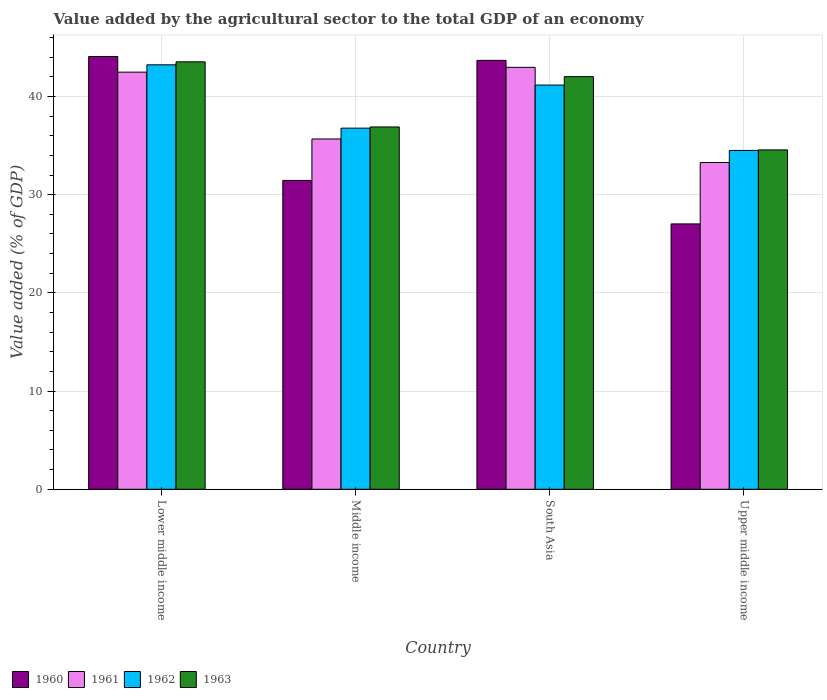How many bars are there on the 4th tick from the right?
Your response must be concise. 4. What is the label of the 2nd group of bars from the left?
Your answer should be very brief. Middle income. What is the value added by the agricultural sector to the total GDP in 1960 in Upper middle income?
Your response must be concise. 27.02. Across all countries, what is the maximum value added by the agricultural sector to the total GDP in 1963?
Offer a very short reply. 43.53. Across all countries, what is the minimum value added by the agricultural sector to the total GDP in 1963?
Offer a very short reply. 34.56. In which country was the value added by the agricultural sector to the total GDP in 1963 maximum?
Your answer should be very brief. Lower middle income. In which country was the value added by the agricultural sector to the total GDP in 1963 minimum?
Offer a very short reply. Upper middle income. What is the total value added by the agricultural sector to the total GDP in 1960 in the graph?
Ensure brevity in your answer.  146.22. What is the difference between the value added by the agricultural sector to the total GDP in 1963 in Middle income and that in South Asia?
Offer a very short reply. -5.13. What is the difference between the value added by the agricultural sector to the total GDP in 1962 in South Asia and the value added by the agricultural sector to the total GDP in 1963 in Middle income?
Your answer should be very brief. 4.27. What is the average value added by the agricultural sector to the total GDP in 1960 per country?
Provide a succinct answer. 36.55. What is the difference between the value added by the agricultural sector to the total GDP of/in 1961 and value added by the agricultural sector to the total GDP of/in 1963 in South Asia?
Your answer should be compact. 0.95. What is the ratio of the value added by the agricultural sector to the total GDP in 1961 in Lower middle income to that in South Asia?
Provide a succinct answer. 0.99. What is the difference between the highest and the second highest value added by the agricultural sector to the total GDP in 1961?
Offer a very short reply. 7.29. What is the difference between the highest and the lowest value added by the agricultural sector to the total GDP in 1960?
Offer a very short reply. 17.05. How many countries are there in the graph?
Your answer should be very brief. 4. Are the values on the major ticks of Y-axis written in scientific E-notation?
Give a very brief answer. No. Does the graph contain any zero values?
Ensure brevity in your answer.  No. What is the title of the graph?
Make the answer very short. Value added by the agricultural sector to the total GDP of an economy. Does "1997" appear as one of the legend labels in the graph?
Keep it short and to the point. No. What is the label or title of the X-axis?
Provide a succinct answer. Country. What is the label or title of the Y-axis?
Offer a terse response. Value added (% of GDP). What is the Value added (% of GDP) in 1960 in Lower middle income?
Provide a succinct answer. 44.07. What is the Value added (% of GDP) in 1961 in Lower middle income?
Make the answer very short. 42.48. What is the Value added (% of GDP) of 1962 in Lower middle income?
Provide a succinct answer. 43.22. What is the Value added (% of GDP) of 1963 in Lower middle income?
Offer a terse response. 43.53. What is the Value added (% of GDP) in 1960 in Middle income?
Ensure brevity in your answer.  31.45. What is the Value added (% of GDP) in 1961 in Middle income?
Offer a very short reply. 35.67. What is the Value added (% of GDP) in 1962 in Middle income?
Offer a very short reply. 36.77. What is the Value added (% of GDP) in 1963 in Middle income?
Offer a terse response. 36.89. What is the Value added (% of GDP) of 1960 in South Asia?
Offer a very short reply. 43.68. What is the Value added (% of GDP) in 1961 in South Asia?
Your answer should be compact. 42.96. What is the Value added (% of GDP) of 1962 in South Asia?
Provide a short and direct response. 41.16. What is the Value added (% of GDP) of 1963 in South Asia?
Your response must be concise. 42.02. What is the Value added (% of GDP) of 1960 in Upper middle income?
Give a very brief answer. 27.02. What is the Value added (% of GDP) of 1961 in Upper middle income?
Ensure brevity in your answer.  33.27. What is the Value added (% of GDP) in 1962 in Upper middle income?
Give a very brief answer. 34.5. What is the Value added (% of GDP) in 1963 in Upper middle income?
Offer a terse response. 34.56. Across all countries, what is the maximum Value added (% of GDP) of 1960?
Keep it short and to the point. 44.07. Across all countries, what is the maximum Value added (% of GDP) in 1961?
Keep it short and to the point. 42.96. Across all countries, what is the maximum Value added (% of GDP) of 1962?
Ensure brevity in your answer.  43.22. Across all countries, what is the maximum Value added (% of GDP) of 1963?
Ensure brevity in your answer.  43.53. Across all countries, what is the minimum Value added (% of GDP) in 1960?
Give a very brief answer. 27.02. Across all countries, what is the minimum Value added (% of GDP) of 1961?
Give a very brief answer. 33.27. Across all countries, what is the minimum Value added (% of GDP) of 1962?
Your response must be concise. 34.5. Across all countries, what is the minimum Value added (% of GDP) of 1963?
Give a very brief answer. 34.56. What is the total Value added (% of GDP) in 1960 in the graph?
Your answer should be compact. 146.22. What is the total Value added (% of GDP) of 1961 in the graph?
Provide a succinct answer. 154.39. What is the total Value added (% of GDP) in 1962 in the graph?
Keep it short and to the point. 155.66. What is the total Value added (% of GDP) in 1963 in the graph?
Your answer should be compact. 157. What is the difference between the Value added (% of GDP) of 1960 in Lower middle income and that in Middle income?
Provide a succinct answer. 12.62. What is the difference between the Value added (% of GDP) in 1961 in Lower middle income and that in Middle income?
Your response must be concise. 6.81. What is the difference between the Value added (% of GDP) of 1962 in Lower middle income and that in Middle income?
Your response must be concise. 6.45. What is the difference between the Value added (% of GDP) in 1963 in Lower middle income and that in Middle income?
Provide a succinct answer. 6.63. What is the difference between the Value added (% of GDP) in 1960 in Lower middle income and that in South Asia?
Make the answer very short. 0.39. What is the difference between the Value added (% of GDP) of 1961 in Lower middle income and that in South Asia?
Ensure brevity in your answer.  -0.49. What is the difference between the Value added (% of GDP) of 1962 in Lower middle income and that in South Asia?
Ensure brevity in your answer.  2.06. What is the difference between the Value added (% of GDP) in 1963 in Lower middle income and that in South Asia?
Your answer should be compact. 1.51. What is the difference between the Value added (% of GDP) of 1960 in Lower middle income and that in Upper middle income?
Keep it short and to the point. 17.05. What is the difference between the Value added (% of GDP) in 1961 in Lower middle income and that in Upper middle income?
Provide a short and direct response. 9.2. What is the difference between the Value added (% of GDP) in 1962 in Lower middle income and that in Upper middle income?
Make the answer very short. 8.72. What is the difference between the Value added (% of GDP) in 1963 in Lower middle income and that in Upper middle income?
Provide a succinct answer. 8.97. What is the difference between the Value added (% of GDP) in 1960 in Middle income and that in South Asia?
Provide a succinct answer. -12.22. What is the difference between the Value added (% of GDP) of 1961 in Middle income and that in South Asia?
Offer a very short reply. -7.29. What is the difference between the Value added (% of GDP) of 1962 in Middle income and that in South Asia?
Your answer should be compact. -4.39. What is the difference between the Value added (% of GDP) of 1963 in Middle income and that in South Asia?
Your answer should be compact. -5.13. What is the difference between the Value added (% of GDP) of 1960 in Middle income and that in Upper middle income?
Keep it short and to the point. 4.43. What is the difference between the Value added (% of GDP) of 1961 in Middle income and that in Upper middle income?
Offer a very short reply. 2.4. What is the difference between the Value added (% of GDP) of 1962 in Middle income and that in Upper middle income?
Your answer should be compact. 2.27. What is the difference between the Value added (% of GDP) of 1963 in Middle income and that in Upper middle income?
Your response must be concise. 2.33. What is the difference between the Value added (% of GDP) of 1960 in South Asia and that in Upper middle income?
Your answer should be compact. 16.65. What is the difference between the Value added (% of GDP) in 1961 in South Asia and that in Upper middle income?
Your response must be concise. 9.69. What is the difference between the Value added (% of GDP) in 1962 in South Asia and that in Upper middle income?
Offer a very short reply. 6.66. What is the difference between the Value added (% of GDP) of 1963 in South Asia and that in Upper middle income?
Offer a terse response. 7.46. What is the difference between the Value added (% of GDP) in 1960 in Lower middle income and the Value added (% of GDP) in 1961 in Middle income?
Make the answer very short. 8.4. What is the difference between the Value added (% of GDP) of 1960 in Lower middle income and the Value added (% of GDP) of 1962 in Middle income?
Keep it short and to the point. 7.29. What is the difference between the Value added (% of GDP) of 1960 in Lower middle income and the Value added (% of GDP) of 1963 in Middle income?
Provide a short and direct response. 7.17. What is the difference between the Value added (% of GDP) of 1961 in Lower middle income and the Value added (% of GDP) of 1962 in Middle income?
Offer a very short reply. 5.7. What is the difference between the Value added (% of GDP) in 1961 in Lower middle income and the Value added (% of GDP) in 1963 in Middle income?
Your response must be concise. 5.58. What is the difference between the Value added (% of GDP) of 1962 in Lower middle income and the Value added (% of GDP) of 1963 in Middle income?
Make the answer very short. 6.33. What is the difference between the Value added (% of GDP) of 1960 in Lower middle income and the Value added (% of GDP) of 1961 in South Asia?
Provide a succinct answer. 1.1. What is the difference between the Value added (% of GDP) of 1960 in Lower middle income and the Value added (% of GDP) of 1962 in South Asia?
Keep it short and to the point. 2.91. What is the difference between the Value added (% of GDP) in 1960 in Lower middle income and the Value added (% of GDP) in 1963 in South Asia?
Ensure brevity in your answer.  2.05. What is the difference between the Value added (% of GDP) in 1961 in Lower middle income and the Value added (% of GDP) in 1962 in South Asia?
Your answer should be very brief. 1.32. What is the difference between the Value added (% of GDP) of 1961 in Lower middle income and the Value added (% of GDP) of 1963 in South Asia?
Provide a succinct answer. 0.46. What is the difference between the Value added (% of GDP) of 1962 in Lower middle income and the Value added (% of GDP) of 1963 in South Asia?
Ensure brevity in your answer.  1.2. What is the difference between the Value added (% of GDP) of 1960 in Lower middle income and the Value added (% of GDP) of 1961 in Upper middle income?
Your answer should be compact. 10.79. What is the difference between the Value added (% of GDP) of 1960 in Lower middle income and the Value added (% of GDP) of 1962 in Upper middle income?
Offer a very short reply. 9.56. What is the difference between the Value added (% of GDP) in 1960 in Lower middle income and the Value added (% of GDP) in 1963 in Upper middle income?
Keep it short and to the point. 9.51. What is the difference between the Value added (% of GDP) in 1961 in Lower middle income and the Value added (% of GDP) in 1962 in Upper middle income?
Provide a short and direct response. 7.97. What is the difference between the Value added (% of GDP) of 1961 in Lower middle income and the Value added (% of GDP) of 1963 in Upper middle income?
Your response must be concise. 7.92. What is the difference between the Value added (% of GDP) in 1962 in Lower middle income and the Value added (% of GDP) in 1963 in Upper middle income?
Keep it short and to the point. 8.66. What is the difference between the Value added (% of GDP) in 1960 in Middle income and the Value added (% of GDP) in 1961 in South Asia?
Provide a short and direct response. -11.51. What is the difference between the Value added (% of GDP) in 1960 in Middle income and the Value added (% of GDP) in 1962 in South Asia?
Ensure brevity in your answer.  -9.71. What is the difference between the Value added (% of GDP) in 1960 in Middle income and the Value added (% of GDP) in 1963 in South Asia?
Your answer should be very brief. -10.57. What is the difference between the Value added (% of GDP) in 1961 in Middle income and the Value added (% of GDP) in 1962 in South Asia?
Your answer should be compact. -5.49. What is the difference between the Value added (% of GDP) of 1961 in Middle income and the Value added (% of GDP) of 1963 in South Asia?
Offer a very short reply. -6.35. What is the difference between the Value added (% of GDP) in 1962 in Middle income and the Value added (% of GDP) in 1963 in South Asia?
Your answer should be compact. -5.25. What is the difference between the Value added (% of GDP) of 1960 in Middle income and the Value added (% of GDP) of 1961 in Upper middle income?
Provide a succinct answer. -1.82. What is the difference between the Value added (% of GDP) in 1960 in Middle income and the Value added (% of GDP) in 1962 in Upper middle income?
Provide a short and direct response. -3.05. What is the difference between the Value added (% of GDP) in 1960 in Middle income and the Value added (% of GDP) in 1963 in Upper middle income?
Ensure brevity in your answer.  -3.11. What is the difference between the Value added (% of GDP) in 1961 in Middle income and the Value added (% of GDP) in 1962 in Upper middle income?
Ensure brevity in your answer.  1.17. What is the difference between the Value added (% of GDP) of 1961 in Middle income and the Value added (% of GDP) of 1963 in Upper middle income?
Provide a succinct answer. 1.11. What is the difference between the Value added (% of GDP) in 1962 in Middle income and the Value added (% of GDP) in 1963 in Upper middle income?
Provide a short and direct response. 2.21. What is the difference between the Value added (% of GDP) of 1960 in South Asia and the Value added (% of GDP) of 1961 in Upper middle income?
Make the answer very short. 10.4. What is the difference between the Value added (% of GDP) of 1960 in South Asia and the Value added (% of GDP) of 1962 in Upper middle income?
Give a very brief answer. 9.17. What is the difference between the Value added (% of GDP) of 1960 in South Asia and the Value added (% of GDP) of 1963 in Upper middle income?
Make the answer very short. 9.11. What is the difference between the Value added (% of GDP) of 1961 in South Asia and the Value added (% of GDP) of 1962 in Upper middle income?
Your response must be concise. 8.46. What is the difference between the Value added (% of GDP) of 1961 in South Asia and the Value added (% of GDP) of 1963 in Upper middle income?
Your answer should be compact. 8.4. What is the difference between the Value added (% of GDP) in 1962 in South Asia and the Value added (% of GDP) in 1963 in Upper middle income?
Make the answer very short. 6.6. What is the average Value added (% of GDP) in 1960 per country?
Keep it short and to the point. 36.55. What is the average Value added (% of GDP) in 1961 per country?
Provide a succinct answer. 38.6. What is the average Value added (% of GDP) of 1962 per country?
Your answer should be compact. 38.91. What is the average Value added (% of GDP) of 1963 per country?
Give a very brief answer. 39.25. What is the difference between the Value added (% of GDP) of 1960 and Value added (% of GDP) of 1961 in Lower middle income?
Make the answer very short. 1.59. What is the difference between the Value added (% of GDP) of 1960 and Value added (% of GDP) of 1962 in Lower middle income?
Provide a succinct answer. 0.85. What is the difference between the Value added (% of GDP) in 1960 and Value added (% of GDP) in 1963 in Lower middle income?
Your answer should be compact. 0.54. What is the difference between the Value added (% of GDP) of 1961 and Value added (% of GDP) of 1962 in Lower middle income?
Your answer should be compact. -0.75. What is the difference between the Value added (% of GDP) in 1961 and Value added (% of GDP) in 1963 in Lower middle income?
Provide a short and direct response. -1.05. What is the difference between the Value added (% of GDP) of 1962 and Value added (% of GDP) of 1963 in Lower middle income?
Your response must be concise. -0.3. What is the difference between the Value added (% of GDP) in 1960 and Value added (% of GDP) in 1961 in Middle income?
Your response must be concise. -4.22. What is the difference between the Value added (% of GDP) of 1960 and Value added (% of GDP) of 1962 in Middle income?
Give a very brief answer. -5.32. What is the difference between the Value added (% of GDP) in 1960 and Value added (% of GDP) in 1963 in Middle income?
Offer a terse response. -5.44. What is the difference between the Value added (% of GDP) in 1961 and Value added (% of GDP) in 1962 in Middle income?
Provide a short and direct response. -1.1. What is the difference between the Value added (% of GDP) of 1961 and Value added (% of GDP) of 1963 in Middle income?
Your answer should be compact. -1.22. What is the difference between the Value added (% of GDP) in 1962 and Value added (% of GDP) in 1963 in Middle income?
Give a very brief answer. -0.12. What is the difference between the Value added (% of GDP) of 1960 and Value added (% of GDP) of 1961 in South Asia?
Offer a terse response. 0.71. What is the difference between the Value added (% of GDP) in 1960 and Value added (% of GDP) in 1962 in South Asia?
Offer a terse response. 2.52. What is the difference between the Value added (% of GDP) of 1960 and Value added (% of GDP) of 1963 in South Asia?
Offer a terse response. 1.66. What is the difference between the Value added (% of GDP) of 1961 and Value added (% of GDP) of 1962 in South Asia?
Your answer should be compact. 1.8. What is the difference between the Value added (% of GDP) of 1961 and Value added (% of GDP) of 1963 in South Asia?
Provide a short and direct response. 0.95. What is the difference between the Value added (% of GDP) of 1962 and Value added (% of GDP) of 1963 in South Asia?
Provide a short and direct response. -0.86. What is the difference between the Value added (% of GDP) in 1960 and Value added (% of GDP) in 1961 in Upper middle income?
Your answer should be compact. -6.25. What is the difference between the Value added (% of GDP) of 1960 and Value added (% of GDP) of 1962 in Upper middle income?
Provide a short and direct response. -7.48. What is the difference between the Value added (% of GDP) in 1960 and Value added (% of GDP) in 1963 in Upper middle income?
Your answer should be compact. -7.54. What is the difference between the Value added (% of GDP) of 1961 and Value added (% of GDP) of 1962 in Upper middle income?
Make the answer very short. -1.23. What is the difference between the Value added (% of GDP) in 1961 and Value added (% of GDP) in 1963 in Upper middle income?
Make the answer very short. -1.29. What is the difference between the Value added (% of GDP) of 1962 and Value added (% of GDP) of 1963 in Upper middle income?
Keep it short and to the point. -0.06. What is the ratio of the Value added (% of GDP) in 1960 in Lower middle income to that in Middle income?
Your response must be concise. 1.4. What is the ratio of the Value added (% of GDP) in 1961 in Lower middle income to that in Middle income?
Keep it short and to the point. 1.19. What is the ratio of the Value added (% of GDP) of 1962 in Lower middle income to that in Middle income?
Keep it short and to the point. 1.18. What is the ratio of the Value added (% of GDP) of 1963 in Lower middle income to that in Middle income?
Your answer should be compact. 1.18. What is the ratio of the Value added (% of GDP) in 1960 in Lower middle income to that in South Asia?
Your response must be concise. 1.01. What is the ratio of the Value added (% of GDP) of 1961 in Lower middle income to that in South Asia?
Provide a short and direct response. 0.99. What is the ratio of the Value added (% of GDP) in 1962 in Lower middle income to that in South Asia?
Your answer should be compact. 1.05. What is the ratio of the Value added (% of GDP) in 1963 in Lower middle income to that in South Asia?
Keep it short and to the point. 1.04. What is the ratio of the Value added (% of GDP) in 1960 in Lower middle income to that in Upper middle income?
Make the answer very short. 1.63. What is the ratio of the Value added (% of GDP) of 1961 in Lower middle income to that in Upper middle income?
Give a very brief answer. 1.28. What is the ratio of the Value added (% of GDP) of 1962 in Lower middle income to that in Upper middle income?
Provide a short and direct response. 1.25. What is the ratio of the Value added (% of GDP) in 1963 in Lower middle income to that in Upper middle income?
Your response must be concise. 1.26. What is the ratio of the Value added (% of GDP) in 1960 in Middle income to that in South Asia?
Make the answer very short. 0.72. What is the ratio of the Value added (% of GDP) in 1961 in Middle income to that in South Asia?
Offer a terse response. 0.83. What is the ratio of the Value added (% of GDP) of 1962 in Middle income to that in South Asia?
Ensure brevity in your answer.  0.89. What is the ratio of the Value added (% of GDP) in 1963 in Middle income to that in South Asia?
Ensure brevity in your answer.  0.88. What is the ratio of the Value added (% of GDP) in 1960 in Middle income to that in Upper middle income?
Your answer should be compact. 1.16. What is the ratio of the Value added (% of GDP) in 1961 in Middle income to that in Upper middle income?
Give a very brief answer. 1.07. What is the ratio of the Value added (% of GDP) of 1962 in Middle income to that in Upper middle income?
Your response must be concise. 1.07. What is the ratio of the Value added (% of GDP) of 1963 in Middle income to that in Upper middle income?
Give a very brief answer. 1.07. What is the ratio of the Value added (% of GDP) of 1960 in South Asia to that in Upper middle income?
Provide a succinct answer. 1.62. What is the ratio of the Value added (% of GDP) of 1961 in South Asia to that in Upper middle income?
Ensure brevity in your answer.  1.29. What is the ratio of the Value added (% of GDP) of 1962 in South Asia to that in Upper middle income?
Your answer should be compact. 1.19. What is the ratio of the Value added (% of GDP) in 1963 in South Asia to that in Upper middle income?
Provide a short and direct response. 1.22. What is the difference between the highest and the second highest Value added (% of GDP) in 1960?
Provide a succinct answer. 0.39. What is the difference between the highest and the second highest Value added (% of GDP) of 1961?
Give a very brief answer. 0.49. What is the difference between the highest and the second highest Value added (% of GDP) in 1962?
Offer a terse response. 2.06. What is the difference between the highest and the second highest Value added (% of GDP) in 1963?
Your response must be concise. 1.51. What is the difference between the highest and the lowest Value added (% of GDP) in 1960?
Make the answer very short. 17.05. What is the difference between the highest and the lowest Value added (% of GDP) in 1961?
Keep it short and to the point. 9.69. What is the difference between the highest and the lowest Value added (% of GDP) in 1962?
Your response must be concise. 8.72. What is the difference between the highest and the lowest Value added (% of GDP) of 1963?
Offer a very short reply. 8.97. 